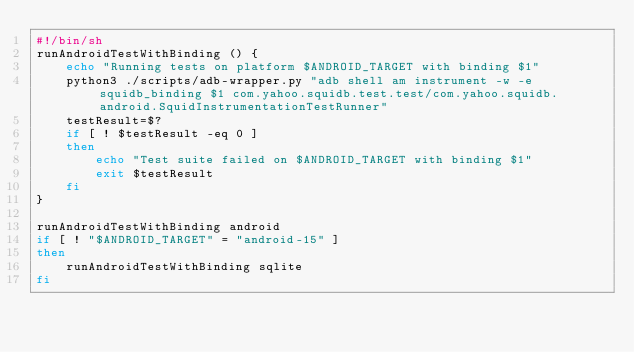<code> <loc_0><loc_0><loc_500><loc_500><_Bash_>#!/bin/sh
runAndroidTestWithBinding () {
    echo "Running tests on platform $ANDROID_TARGET with binding $1"
    python3 ./scripts/adb-wrapper.py "adb shell am instrument -w -e squidb_binding $1 com.yahoo.squidb.test.test/com.yahoo.squidb.android.SquidInstrumentationTestRunner"
    testResult=$?
    if [ ! $testResult -eq 0 ]
    then
        echo "Test suite failed on $ANDROID_TARGET with binding $1"
        exit $testResult
    fi
}

runAndroidTestWithBinding android
if [ ! "$ANDROID_TARGET" = "android-15" ]
then
    runAndroidTestWithBinding sqlite
fi
</code> 